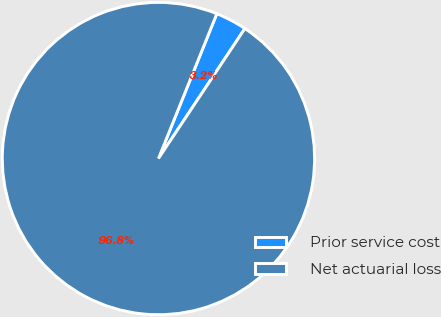<chart> <loc_0><loc_0><loc_500><loc_500><pie_chart><fcel>Prior service cost<fcel>Net actuarial loss<nl><fcel>3.24%<fcel>96.76%<nl></chart> 